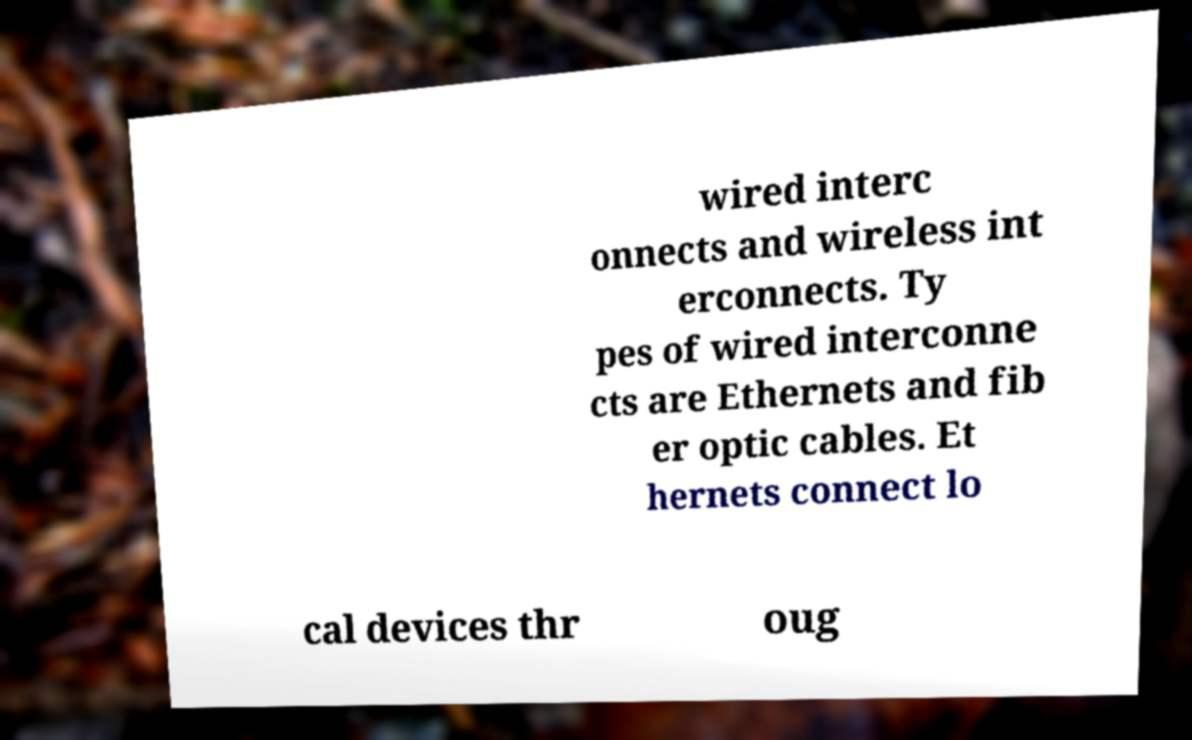Please read and relay the text visible in this image. What does it say? wired interc onnects and wireless int erconnects. Ty pes of wired interconne cts are Ethernets and fib er optic cables. Et hernets connect lo cal devices thr oug 